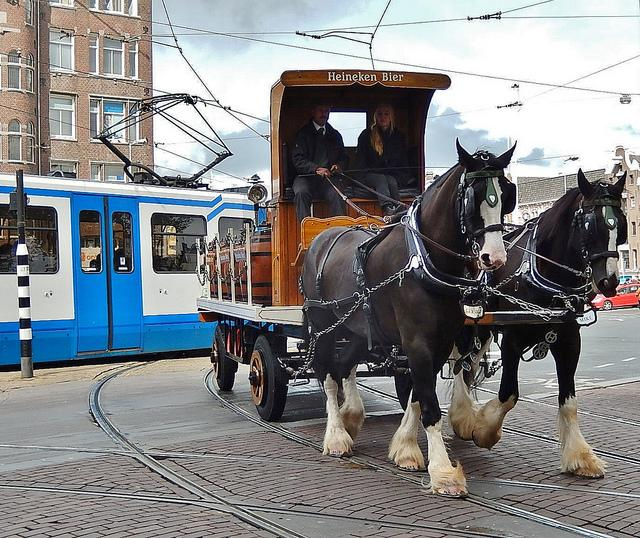What sort of product do ad men use these type horses to market? beer 